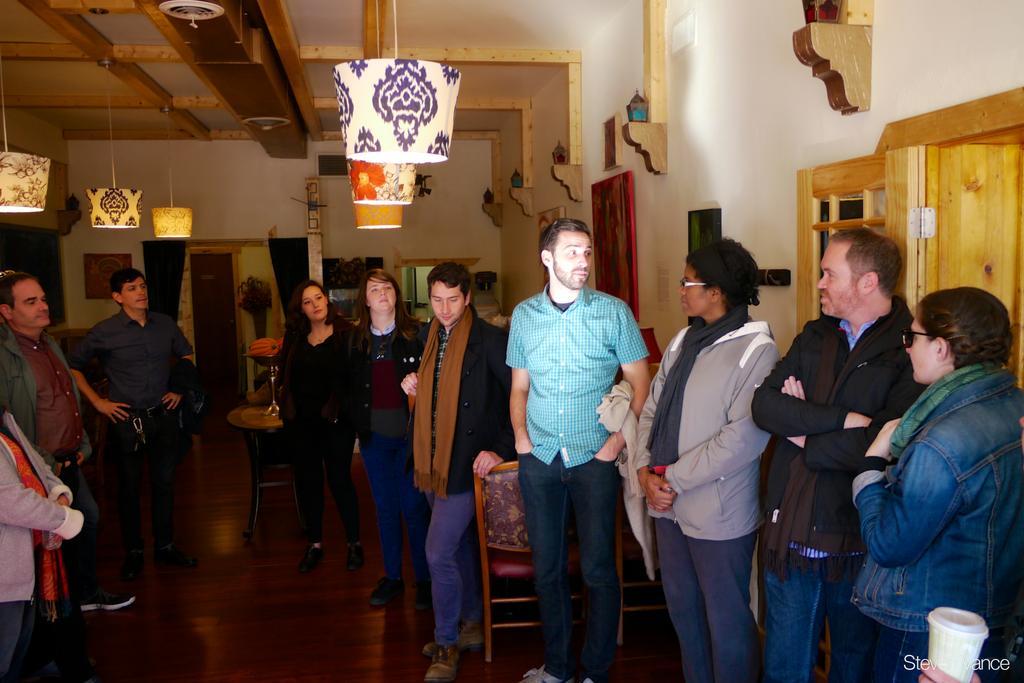Please provide a concise description of this image. In this image we can see there are a few people standing on the floor. In the background there are some photo frames attached to the wall. At the top of the image there is a ceiling and lamps. 